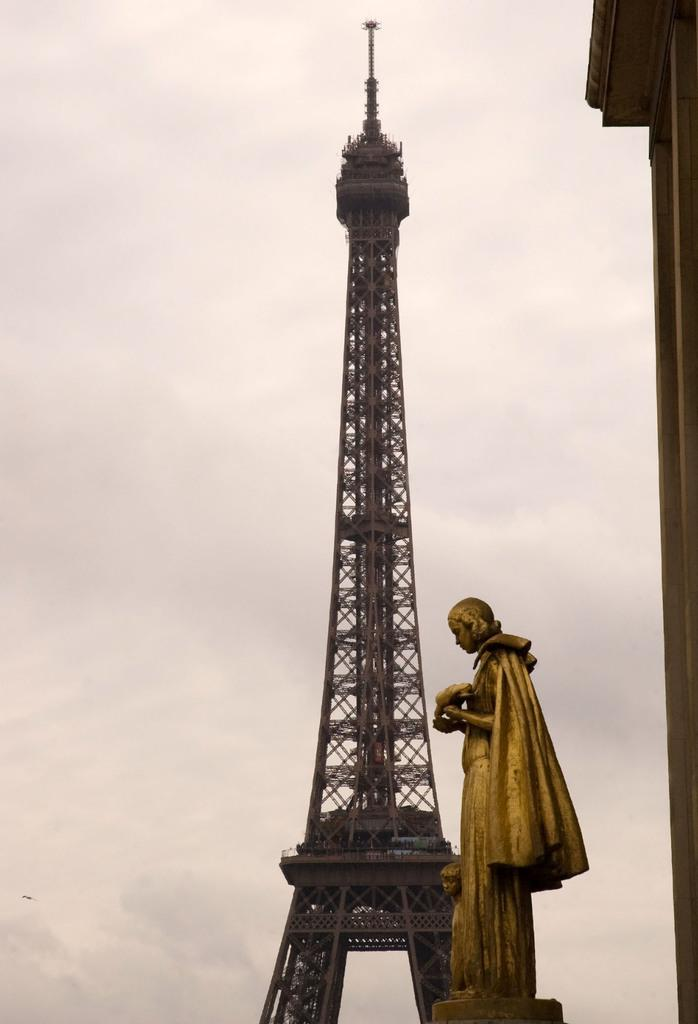What is the main subject in the front of the image? There is a statue in the front of the image. What can be seen in the background of the image? There is a tower in the background of the image. What is visible at the top of the image? The sky is visible at the top of the image. How many giants are standing next to the statue in the image? There are no giants present in the image; it features a statue and a tower. What type of throat condition can be seen in the image? There is no throat condition present in the image; it features a statue, a tower, and the sky. 